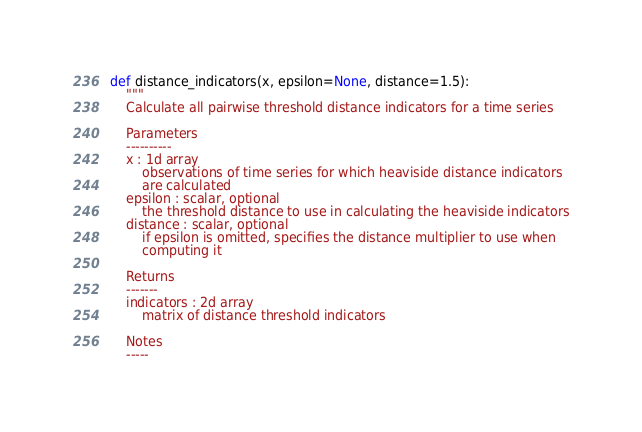<code> <loc_0><loc_0><loc_500><loc_500><_Python_>def distance_indicators(x, epsilon=None, distance=1.5):
    """
    Calculate all pairwise threshold distance indicators for a time series

    Parameters
    ----------
    x : 1d array
        observations of time series for which heaviside distance indicators
        are calculated
    epsilon : scalar, optional
        the threshold distance to use in calculating the heaviside indicators
    distance : scalar, optional
        if epsilon is omitted, specifies the distance multiplier to use when
        computing it

    Returns
    -------
    indicators : 2d array
        matrix of distance threshold indicators

    Notes
    -----</code> 